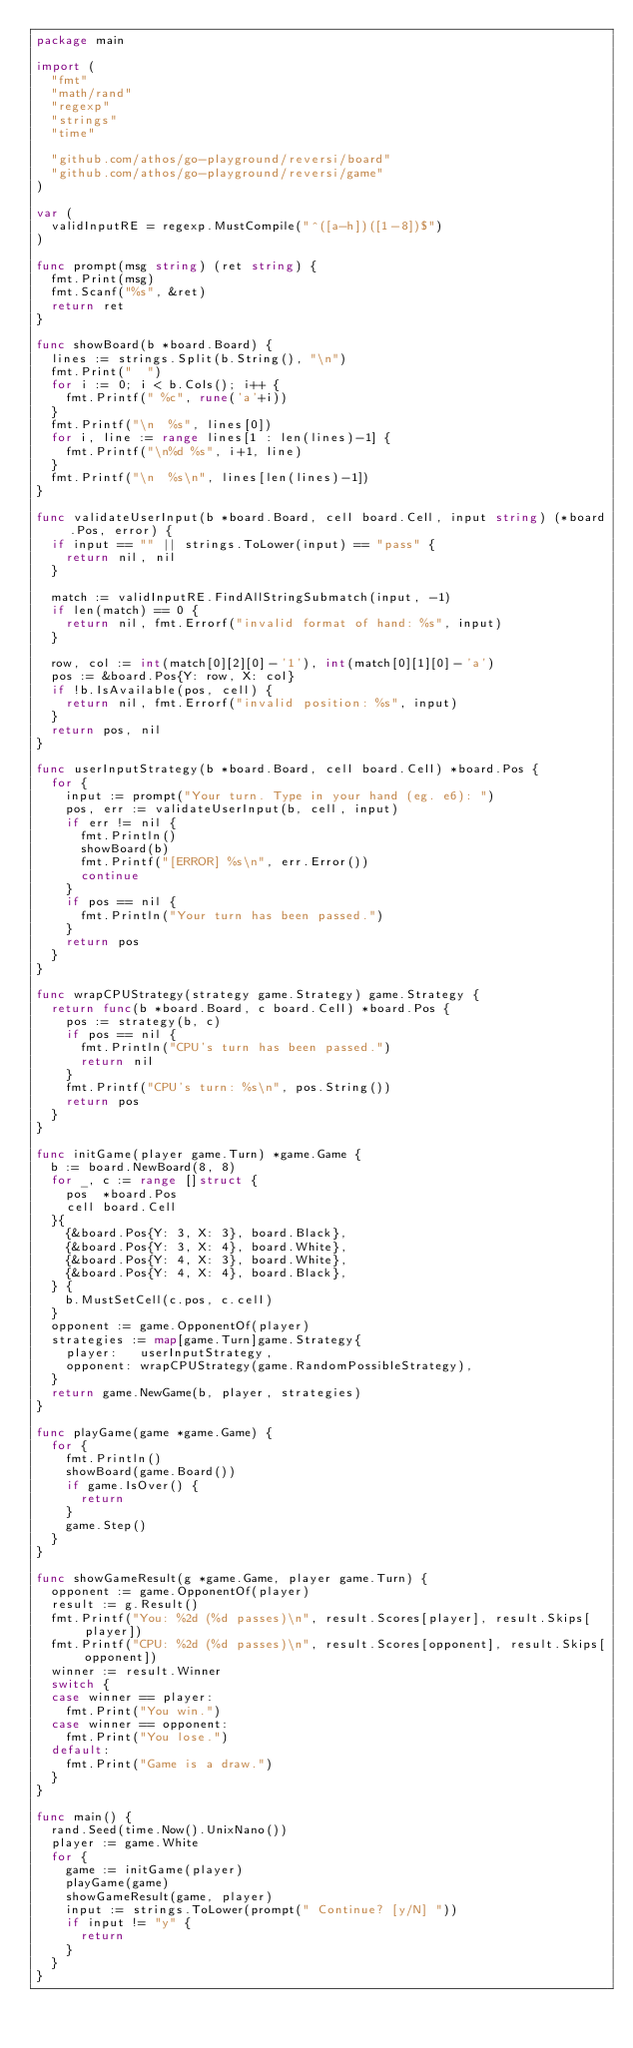Convert code to text. <code><loc_0><loc_0><loc_500><loc_500><_Go_>package main

import (
	"fmt"
	"math/rand"
	"regexp"
	"strings"
	"time"

	"github.com/athos/go-playground/reversi/board"
	"github.com/athos/go-playground/reversi/game"
)

var (
	validInputRE = regexp.MustCompile("^([a-h])([1-8])$")
)

func prompt(msg string) (ret string) {
	fmt.Print(msg)
	fmt.Scanf("%s", &ret)
	return ret
}

func showBoard(b *board.Board) {
	lines := strings.Split(b.String(), "\n")
	fmt.Print("  ")
	for i := 0; i < b.Cols(); i++ {
		fmt.Printf(" %c", rune('a'+i))
	}
	fmt.Printf("\n  %s", lines[0])
	for i, line := range lines[1 : len(lines)-1] {
		fmt.Printf("\n%d %s", i+1, line)
	}
	fmt.Printf("\n  %s\n", lines[len(lines)-1])
}

func validateUserInput(b *board.Board, cell board.Cell, input string) (*board.Pos, error) {
	if input == "" || strings.ToLower(input) == "pass" {
		return nil, nil
	}

	match := validInputRE.FindAllStringSubmatch(input, -1)
	if len(match) == 0 {
		return nil, fmt.Errorf("invalid format of hand: %s", input)
	}

	row, col := int(match[0][2][0]-'1'), int(match[0][1][0]-'a')
	pos := &board.Pos{Y: row, X: col}
	if !b.IsAvailable(pos, cell) {
		return nil, fmt.Errorf("invalid position: %s", input)
	}
	return pos, nil
}

func userInputStrategy(b *board.Board, cell board.Cell) *board.Pos {
	for {
		input := prompt("Your turn. Type in your hand (eg. e6): ")
		pos, err := validateUserInput(b, cell, input)
		if err != nil {
			fmt.Println()
			showBoard(b)
			fmt.Printf("[ERROR] %s\n", err.Error())
			continue
		}
		if pos == nil {
			fmt.Println("Your turn has been passed.")
		}
		return pos
	}
}

func wrapCPUStrategy(strategy game.Strategy) game.Strategy {
	return func(b *board.Board, c board.Cell) *board.Pos {
		pos := strategy(b, c)
		if pos == nil {
			fmt.Println("CPU's turn has been passed.")
			return nil
		}
		fmt.Printf("CPU's turn: %s\n", pos.String())
		return pos
	}
}

func initGame(player game.Turn) *game.Game {
	b := board.NewBoard(8, 8)
	for _, c := range []struct {
		pos  *board.Pos
		cell board.Cell
	}{
		{&board.Pos{Y: 3, X: 3}, board.Black},
		{&board.Pos{Y: 3, X: 4}, board.White},
		{&board.Pos{Y: 4, X: 3}, board.White},
		{&board.Pos{Y: 4, X: 4}, board.Black},
	} {
		b.MustSetCell(c.pos, c.cell)
	}
	opponent := game.OpponentOf(player)
	strategies := map[game.Turn]game.Strategy{
		player:   userInputStrategy,
		opponent: wrapCPUStrategy(game.RandomPossibleStrategy),
	}
	return game.NewGame(b, player, strategies)
}

func playGame(game *game.Game) {
	for {
		fmt.Println()
		showBoard(game.Board())
		if game.IsOver() {
			return
		}
		game.Step()
	}
}

func showGameResult(g *game.Game, player game.Turn) {
	opponent := game.OpponentOf(player)
	result := g.Result()
	fmt.Printf("You: %2d (%d passes)\n", result.Scores[player], result.Skips[player])
	fmt.Printf("CPU: %2d (%d passes)\n", result.Scores[opponent], result.Skips[opponent])
	winner := result.Winner
	switch {
	case winner == player:
		fmt.Print("You win.")
	case winner == opponent:
		fmt.Print("You lose.")
	default:
		fmt.Print("Game is a draw.")
	}
}

func main() {
	rand.Seed(time.Now().UnixNano())
	player := game.White
	for {
		game := initGame(player)
		playGame(game)
		showGameResult(game, player)
		input := strings.ToLower(prompt(" Continue? [y/N] "))
		if input != "y" {
			return
		}
	}
}
</code> 